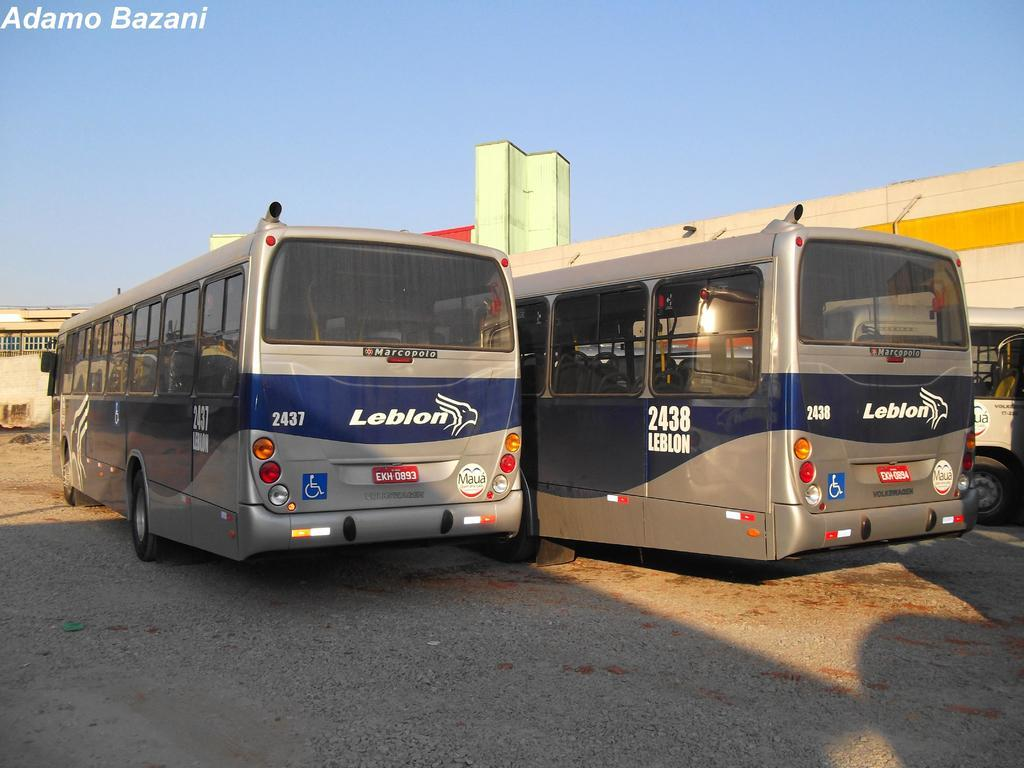What is the main subject of the image? The main subject of the image is buses, which are located in the center of the image. What can be seen in the background of the image? There are buildings in the background of the image. What is visible at the top of the image? The sky is visible at the top of the image. What type of creature can be seen providing shade for the buses in the image? There is no creature present in the image, and therefore no creature can be seen providing shade for the buses. 